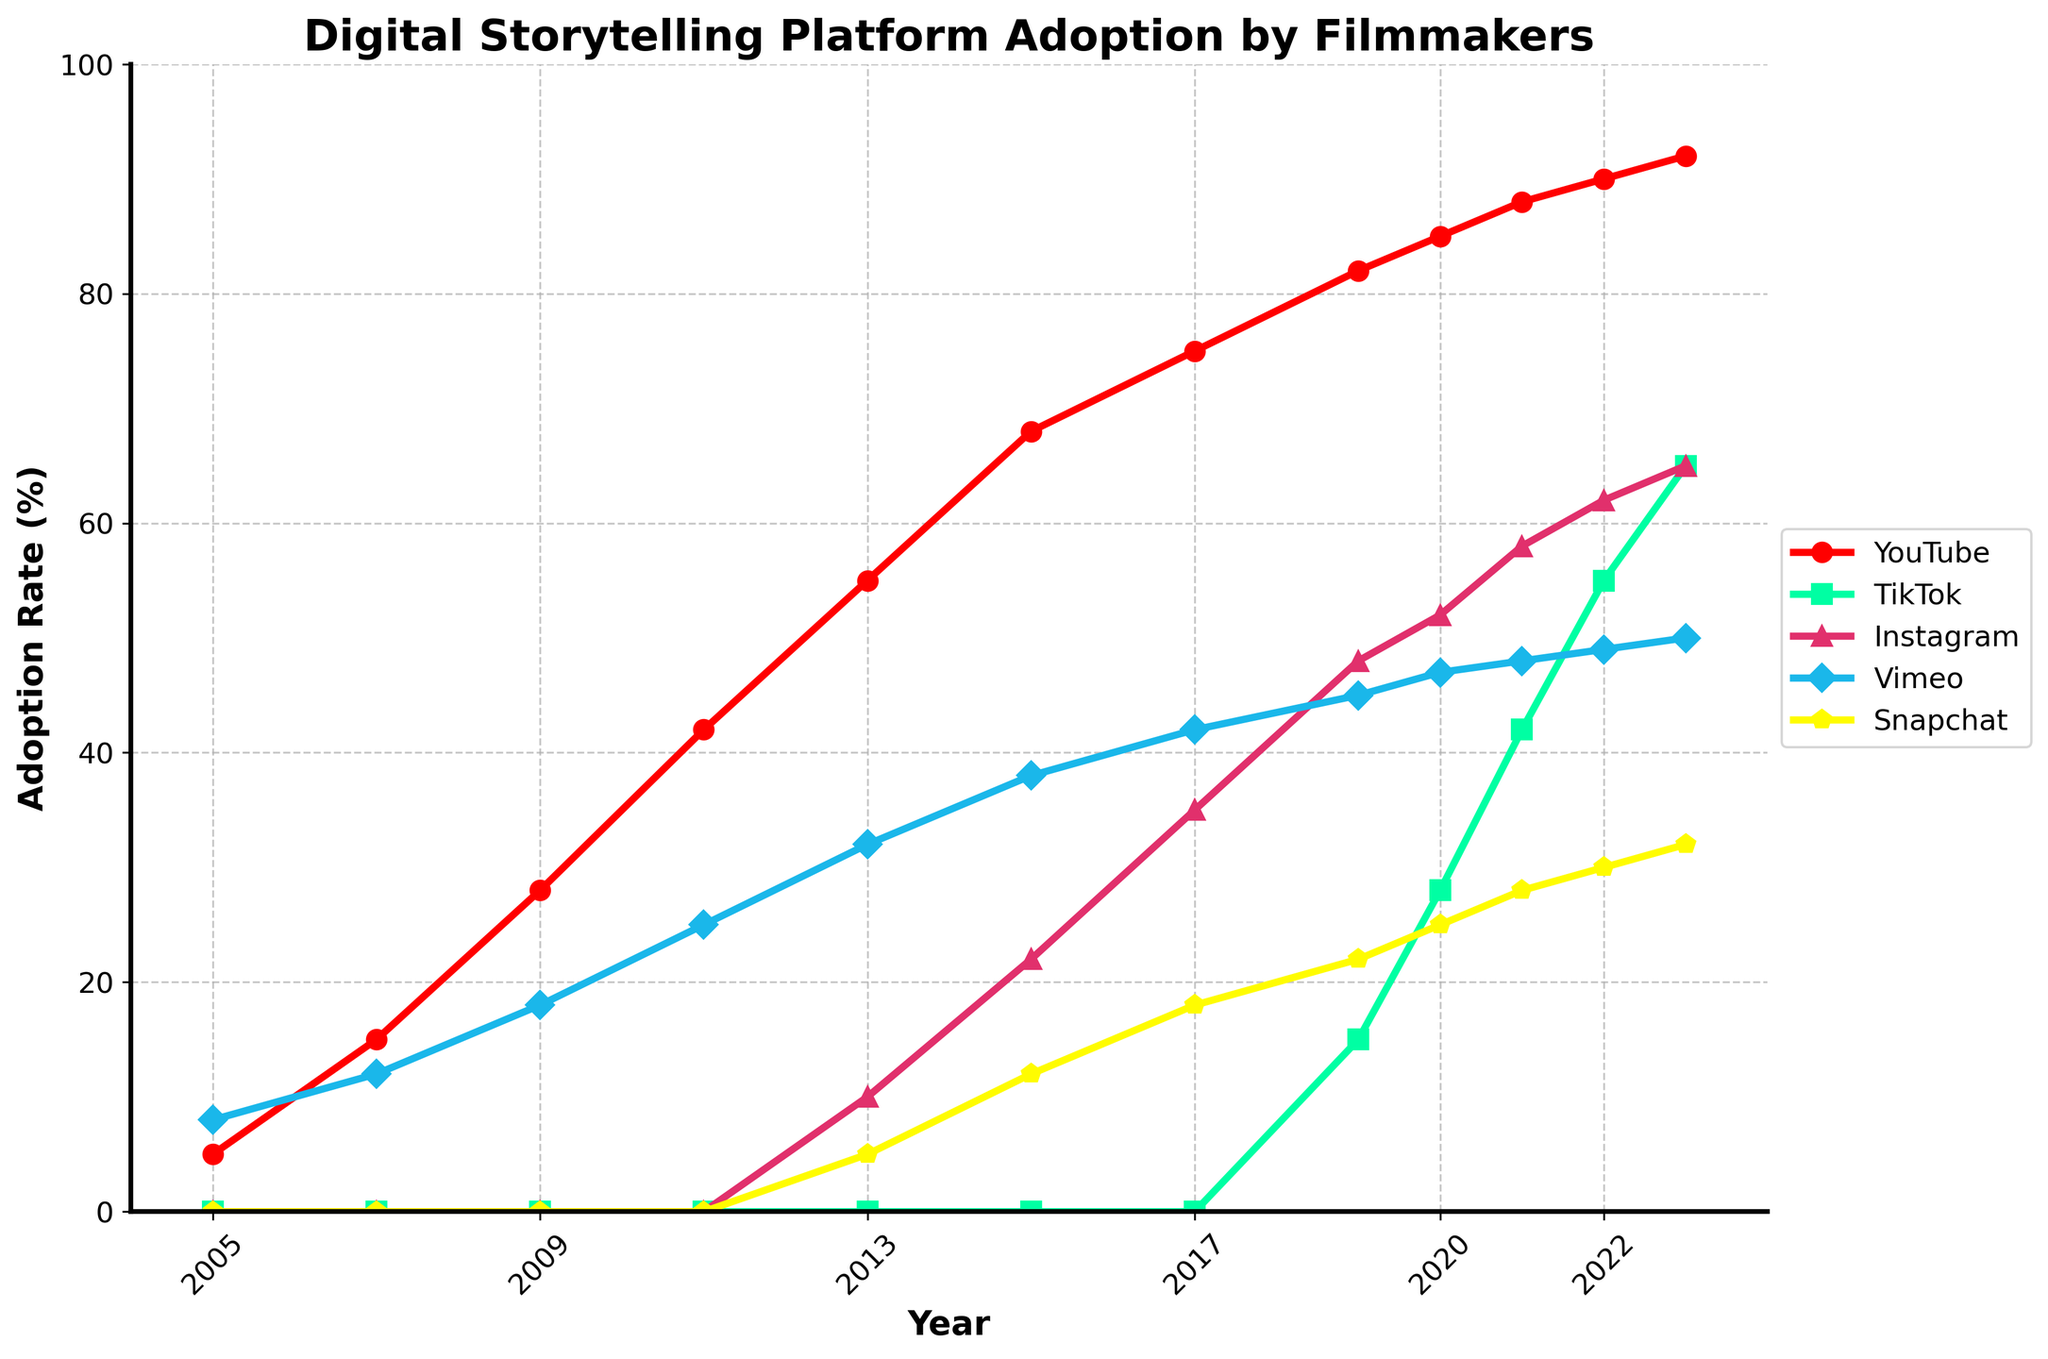What's the adoption rate of YouTube in 2023? The data for the adoption rate of YouTube in 2023 is shown by the red line at the 2023 mark on the x-axis.
Answer: 92% Which platform had the highest adoption rate in 2023? By comparing the endpoints of each colored line at the x-axis value of 2023, the red line (YouTube) is the highest.
Answer: YouTube How did TikTok's adoption rate change between 2019 and 2023? By observing the turquoise line at 2019 and 2023, TikTok's adoption rate increases from 15% in 2019 to 65% in 2023.
Answer: Increased by 50% What year did Instagram first surpass a 50% adoption rate? Observing the pink line for Instagram, it crosses the 50% mark just before 2021.
Answer: 2021 Between which years did Vimeo's adoption rate increase the most? The light-blue line shows Vimeo had the steepest increase from 2005 to around 2013, with notable increases each year.
Answer: 2005 to 2013 What’s the cumulative increase in YouTube’s adoption rate from 2005 to 2023? Calculating the difference between YouTube's adoption rates in 2023 and 2005: 92% - 5% = 87%.
Answer: 87% Which platform had the slowest adoption rate increase over the given period? Observing the slope of each line, Snapchat (yellow) increases the slowest.
Answer: Snapchat How do Vimeo’s and YouTube’s adoption rates in 2011 compare? At 2011, Vimeo's adoption rate is represented by the light-blue line (25%) and YouTube's by the red line (42%).
Answer: YouTube is higher What is the combined total adoption rate of Instagram and TikTok in 2023? Adding Instagram's 65% and TikTok's 65% adoption rates in 2023: 65% + 65% = 130%.
Answer: 130% Which platform had the largest increase in adoption rate from 2021 to 2023? Comparing the slope of each line from 2021 to 2023, TikTok (turquoise) had the steepest increase from 42% to 65%.
Answer: TikTok 